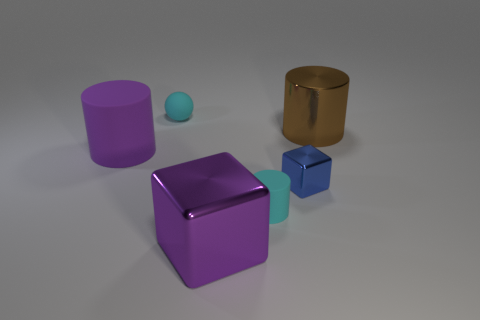There is a tiny cyan thing in front of the sphere; is its shape the same as the purple object that is left of the big cube?
Make the answer very short. Yes. There is a large thing in front of the big matte object; what is its material?
Ensure brevity in your answer.  Metal. There is a thing that is the same color as the small ball; what is its size?
Provide a succinct answer. Small. What number of things are either matte cylinders that are in front of the large purple rubber object or cylinders?
Your response must be concise. 3. Is the number of big purple matte objects that are behind the sphere the same as the number of small yellow matte cubes?
Offer a very short reply. Yes. Do the brown cylinder and the sphere have the same size?
Your response must be concise. No. The metallic block that is the same size as the cyan cylinder is what color?
Your answer should be compact. Blue. There is a cyan rubber sphere; is it the same size as the metallic object in front of the blue object?
Ensure brevity in your answer.  No. What number of small rubber cylinders have the same color as the large rubber cylinder?
Ensure brevity in your answer.  0. How many objects are purple things or small rubber objects that are in front of the tiny metal block?
Your answer should be compact. 3. 